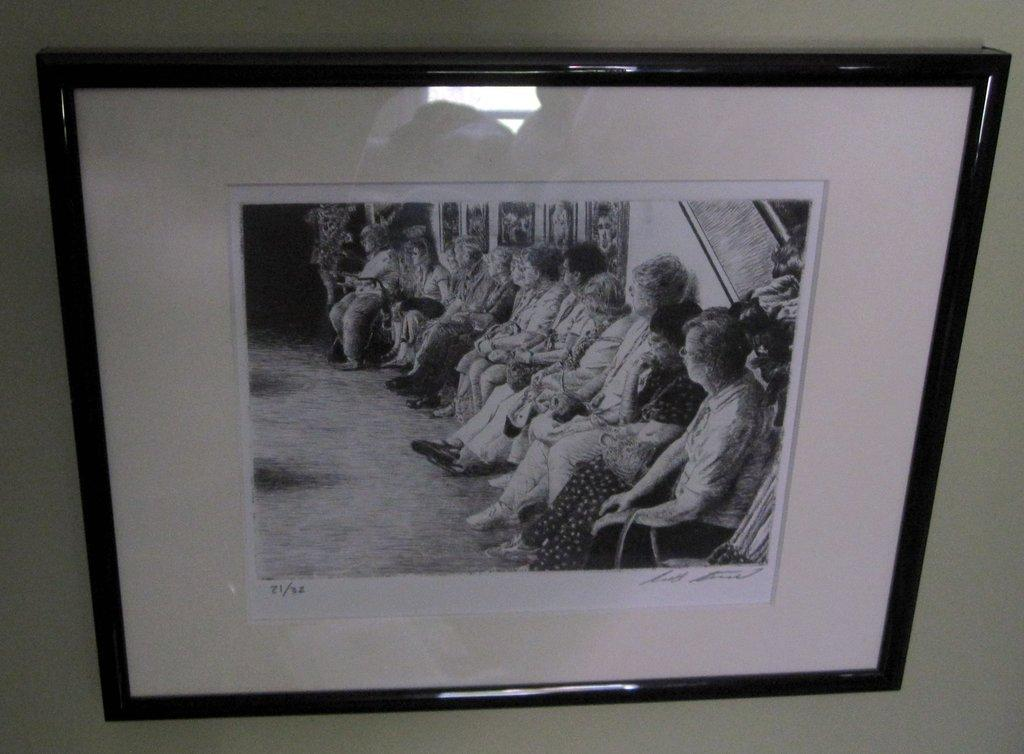<image>
Render a clear and concise summary of the photo. Picture framed on a wall showing some women sitting down and the numbers 21 and 32. 